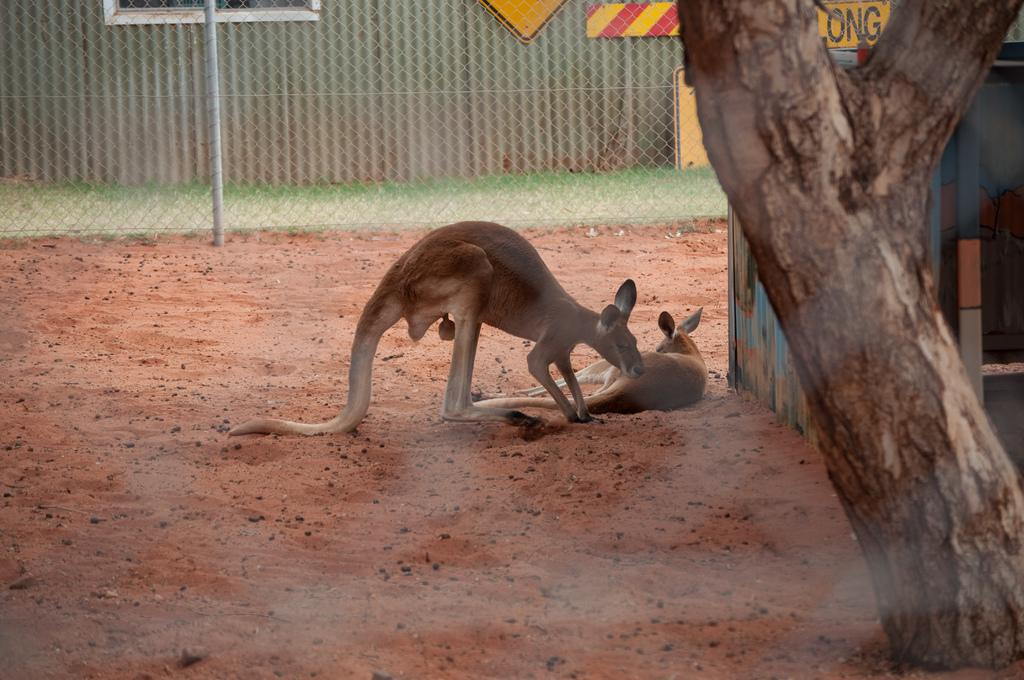What type of animals can be seen in the image? There are two brown animals in the image. What structure is located to the right of the image? There is a shed to the right of the image. What type of vegetation is present in the image? There are trees in the image. What can be seen in the background of the image? There is a pole and boards to the railing in the background of the image. What type of scent can be detected from the animals in the image? There is no information about the scent of the animals in the image, so it cannot be determined. 